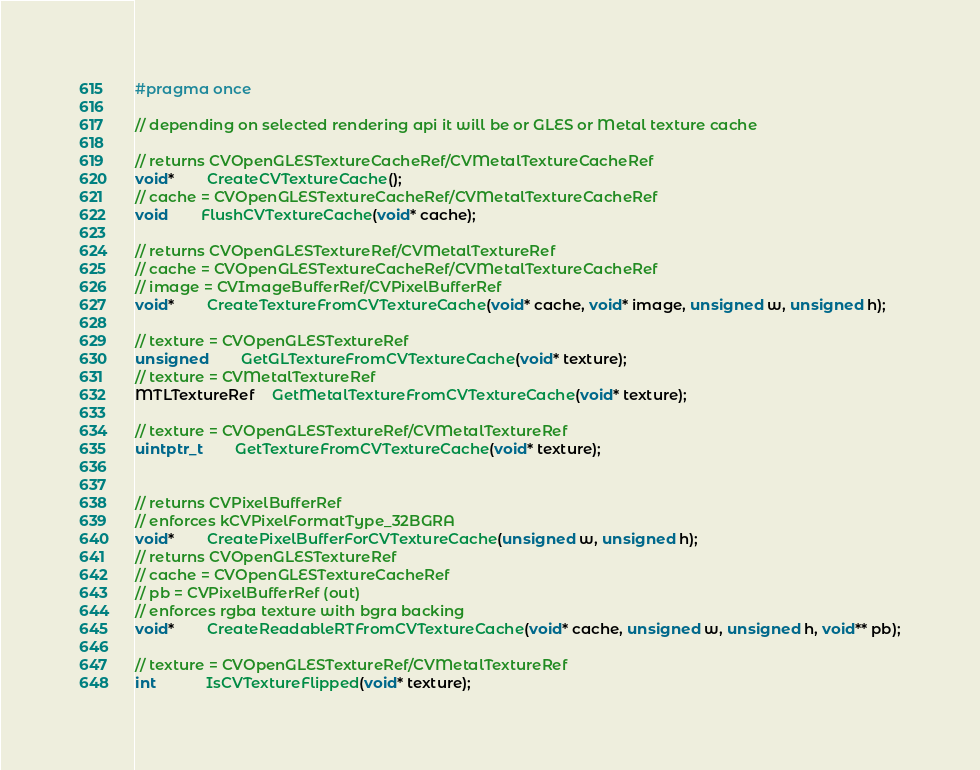Convert code to text. <code><loc_0><loc_0><loc_500><loc_500><_C_>#pragma once

// depending on selected rendering api it will be or GLES or Metal texture cache

// returns CVOpenGLESTextureCacheRef/CVMetalTextureCacheRef
void*		CreateCVTextureCache();
// cache = CVOpenGLESTextureCacheRef/CVMetalTextureCacheRef
void		FlushCVTextureCache(void* cache);

// returns CVOpenGLESTextureRef/CVMetalTextureRef
// cache = CVOpenGLESTextureCacheRef/CVMetalTextureCacheRef
// image = CVImageBufferRef/CVPixelBufferRef
void*		CreateTextureFromCVTextureCache(void* cache, void* image, unsigned w, unsigned h);

// texture = CVOpenGLESTextureRef
unsigned		GetGLTextureFromCVTextureCache(void* texture);
// texture = CVMetalTextureRef
MTLTextureRef	GetMetalTextureFromCVTextureCache(void* texture);

// texture = CVOpenGLESTextureRef/CVMetalTextureRef
uintptr_t		GetTextureFromCVTextureCache(void* texture);


// returns CVPixelBufferRef
// enforces kCVPixelFormatType_32BGRA
void*		CreatePixelBufferForCVTextureCache(unsigned w, unsigned h);
// returns CVOpenGLESTextureRef
// cache = CVOpenGLESTextureCacheRef
// pb = CVPixelBufferRef (out)
// enforces rgba texture with bgra backing
void*		CreateReadableRTFromCVTextureCache(void* cache, unsigned w, unsigned h, void** pb);

// texture = CVOpenGLESTextureRef/CVMetalTextureRef
int			IsCVTextureFlipped(void* texture);
</code> 